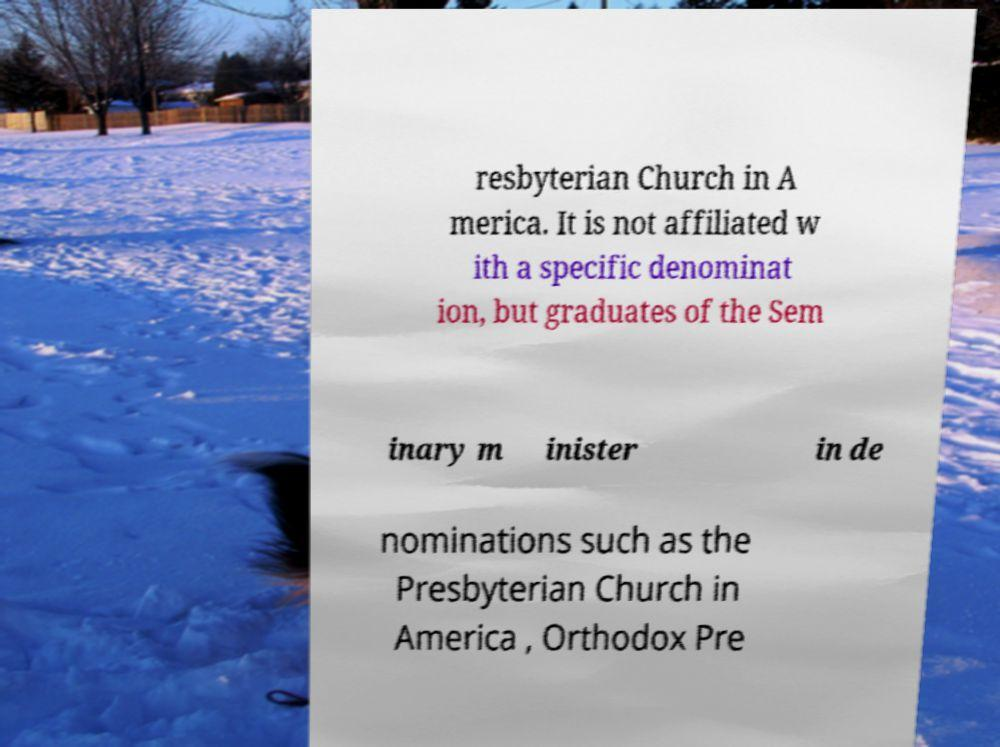There's text embedded in this image that I need extracted. Can you transcribe it verbatim? resbyterian Church in A merica. It is not affiliated w ith a specific denominat ion, but graduates of the Sem inary m inister in de nominations such as the Presbyterian Church in America , Orthodox Pre 